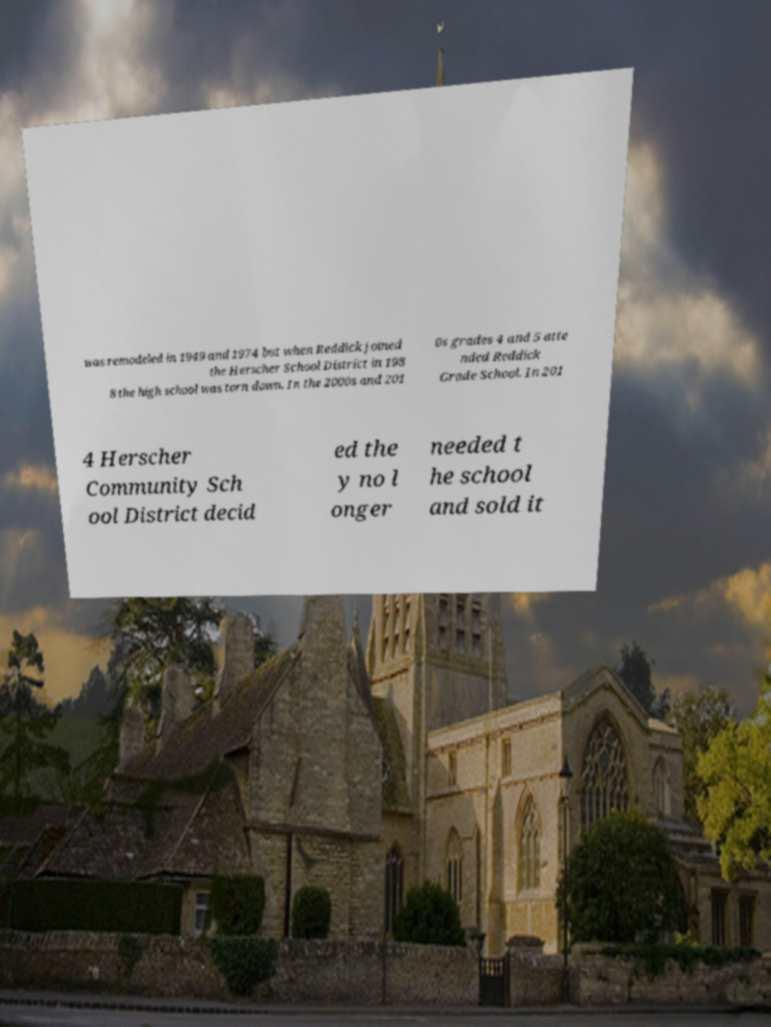What messages or text are displayed in this image? I need them in a readable, typed format. was remodeled in 1949 and 1974 but when Reddick joined the Herscher School District in 198 8 the high school was torn down. In the 2000s and 201 0s grades 4 and 5 atte nded Reddick Grade School. In 201 4 Herscher Community Sch ool District decid ed the y no l onger needed t he school and sold it 